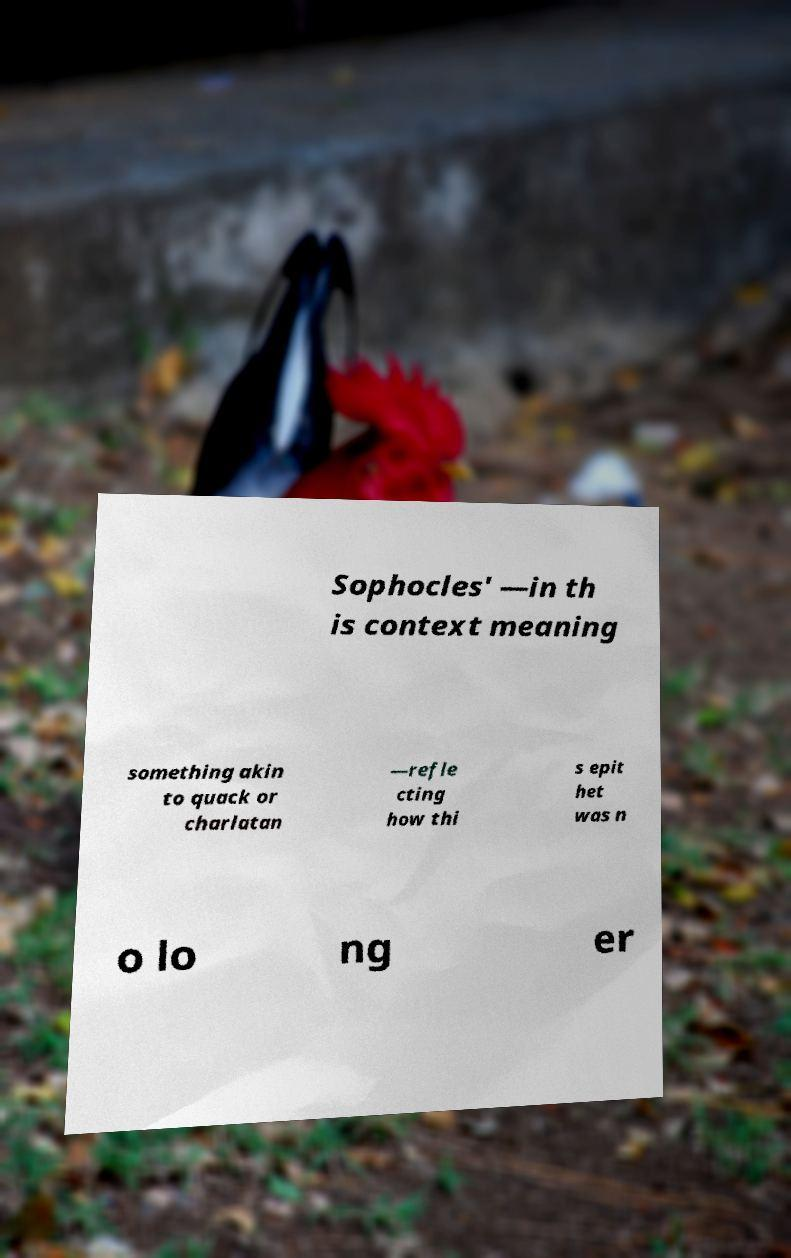For documentation purposes, I need the text within this image transcribed. Could you provide that? Sophocles' —in th is context meaning something akin to quack or charlatan —refle cting how thi s epit het was n o lo ng er 